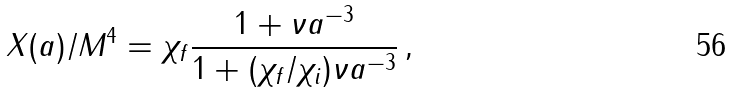<formula> <loc_0><loc_0><loc_500><loc_500>X ( a ) / M ^ { 4 } = \chi _ { f } \frac { 1 + \nu a ^ { - 3 } } { 1 + ( \chi _ { f } / \chi _ { i } ) \nu a ^ { - 3 } } \, ,</formula> 